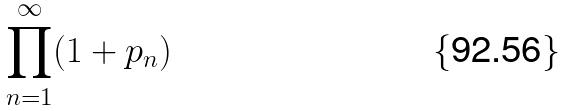<formula> <loc_0><loc_0><loc_500><loc_500>\prod _ { n = 1 } ^ { \infty } ( 1 + p _ { n } )</formula> 